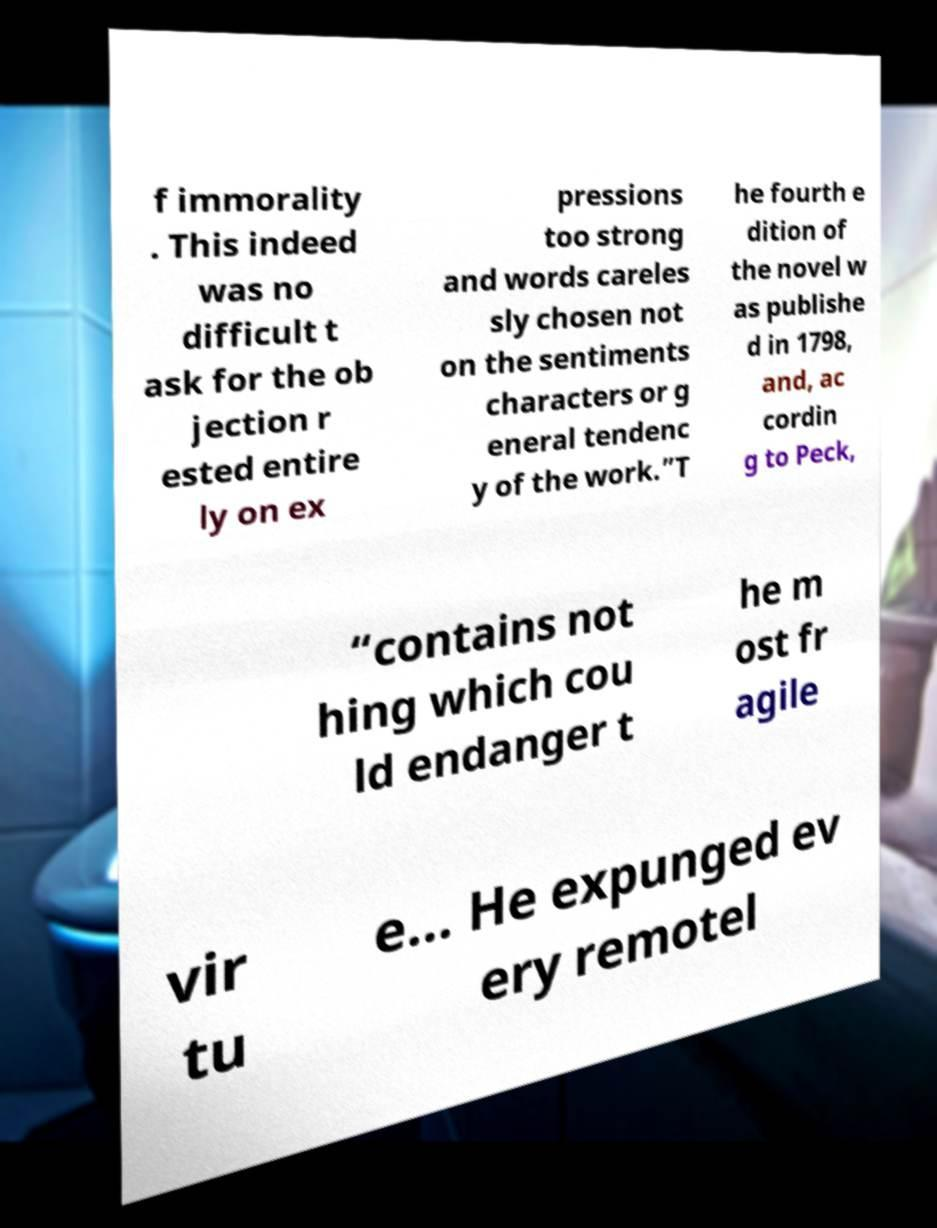For documentation purposes, I need the text within this image transcribed. Could you provide that? f immorality . This indeed was no difficult t ask for the ob jection r ested entire ly on ex pressions too strong and words careles sly chosen not on the sentiments characters or g eneral tendenc y of the work.”T he fourth e dition of the novel w as publishe d in 1798, and, ac cordin g to Peck, “contains not hing which cou ld endanger t he m ost fr agile vir tu e... He expunged ev ery remotel 